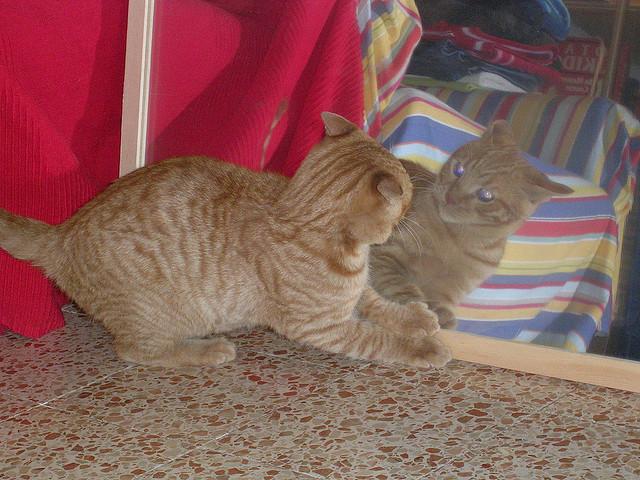Is there a mirror?
Be succinct. Yes. What color is the cat?
Concise answer only. Tan. Is this cat happy with its reflection?
Give a very brief answer. No. How many cat's in the photo?
Write a very short answer. 1. Is this cat content?
Give a very brief answer. No. 